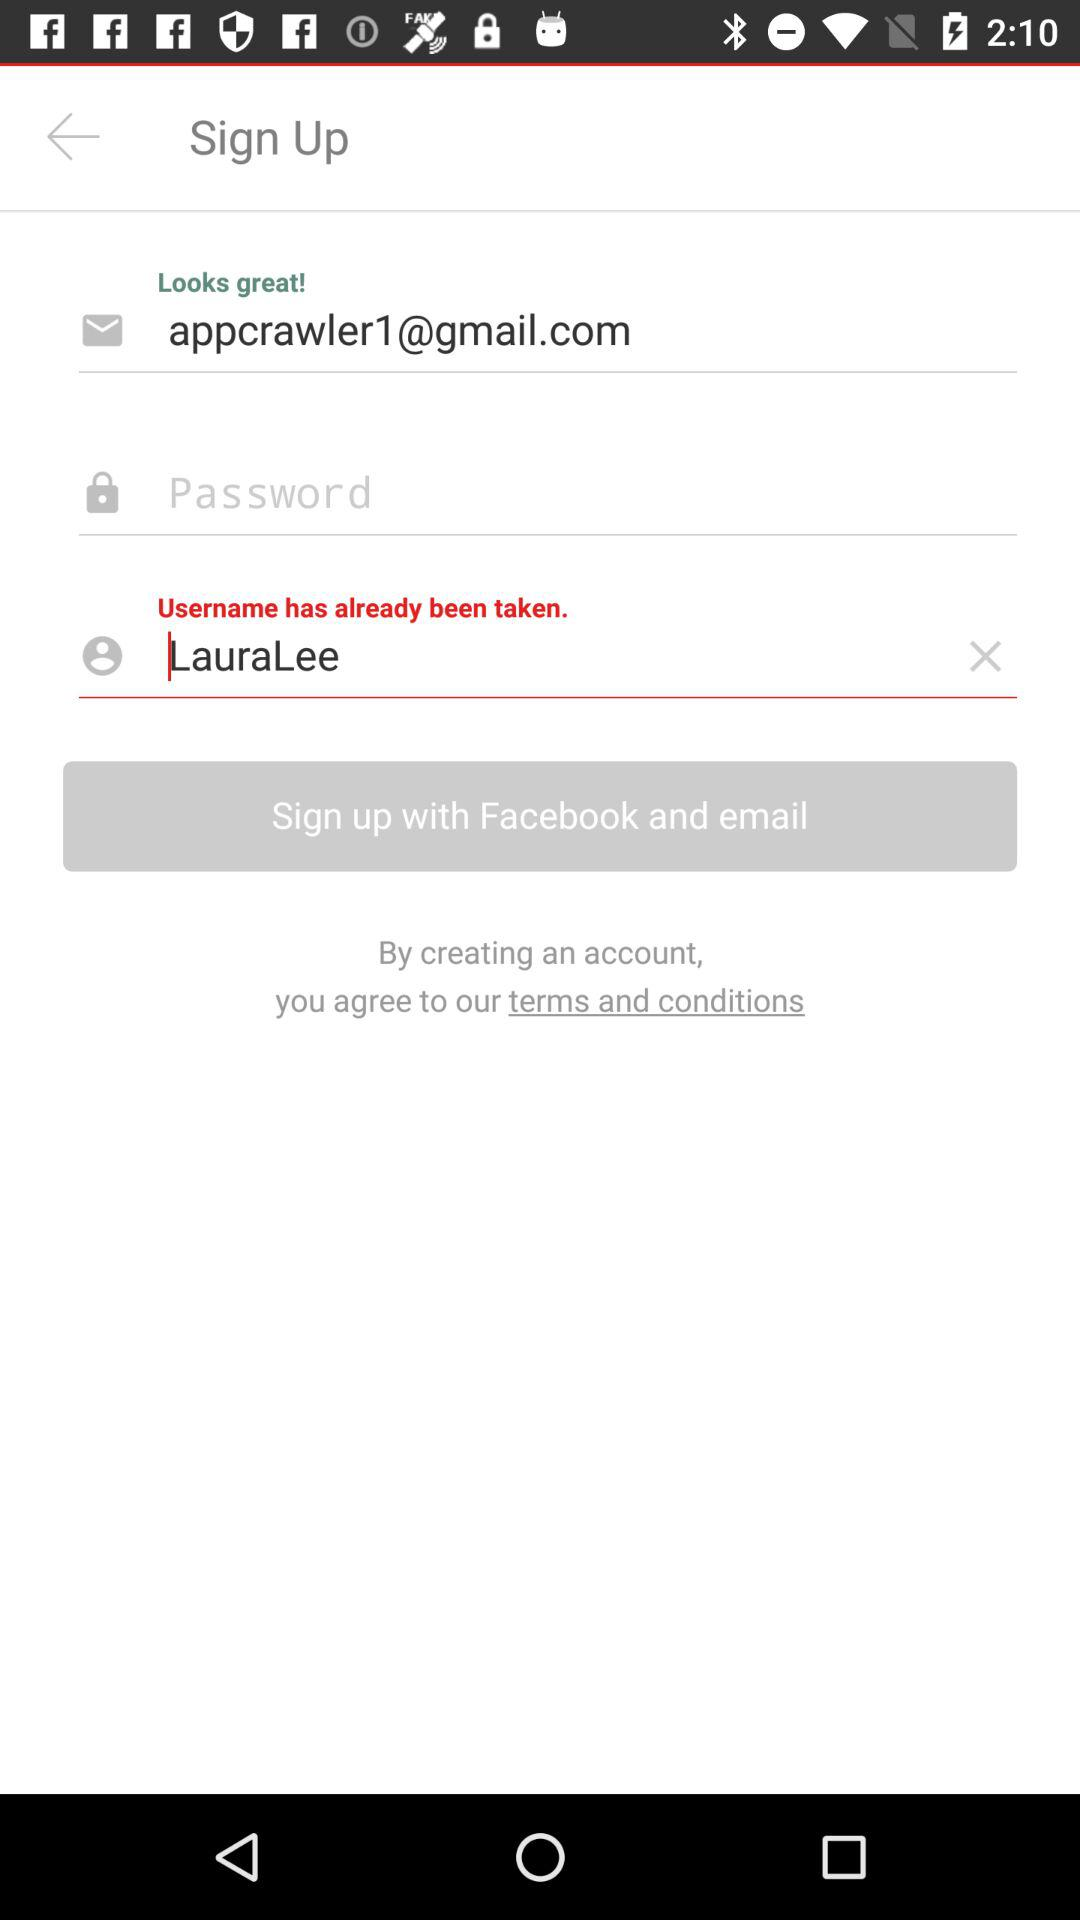What are the different applications with which we can sign up? You can sign up with "Facebook". 